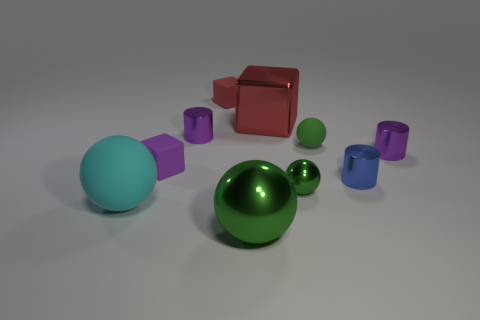How many other things are the same size as the cyan object? On closer examination, there are 2 objects that appear to be roughly the same size as the cyan sphere. These objects are the green sphere and the red cube. 